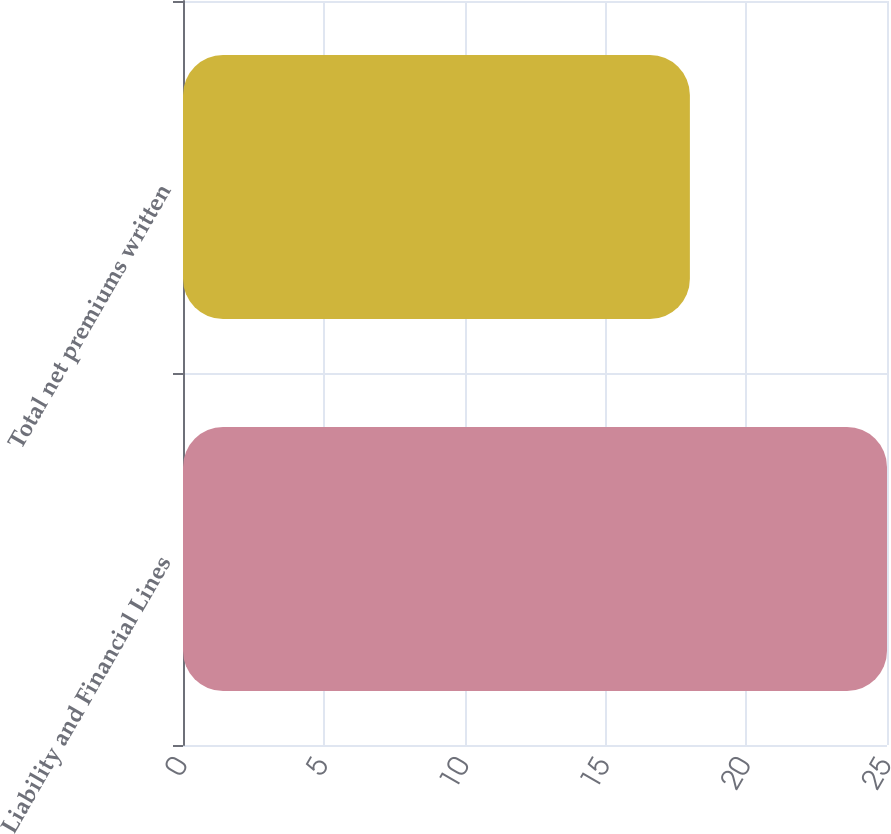<chart> <loc_0><loc_0><loc_500><loc_500><bar_chart><fcel>Liability and Financial Lines<fcel>Total net premiums written<nl><fcel>25<fcel>18<nl></chart> 